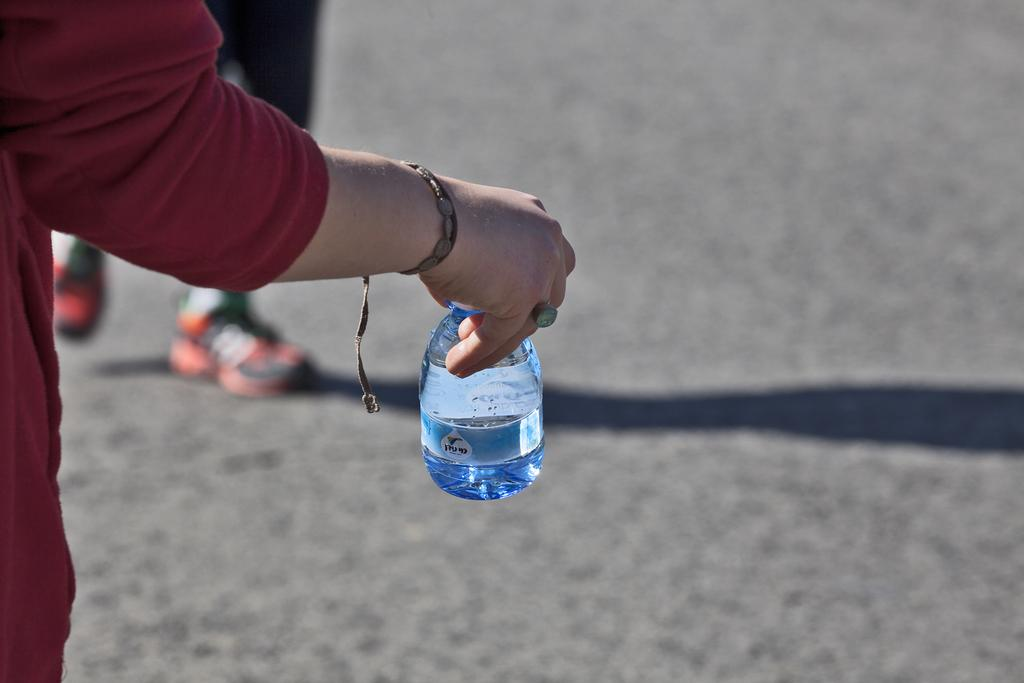What is the hand holding in the image? The hand is holding a bottle in the image. What other object related to a person can be seen in the image? There is a shoe of a person in the image. Where is the nest located in the image? There is no nest present in the image. How many cakes are visible in the image? There are no cakes visible in the image. 